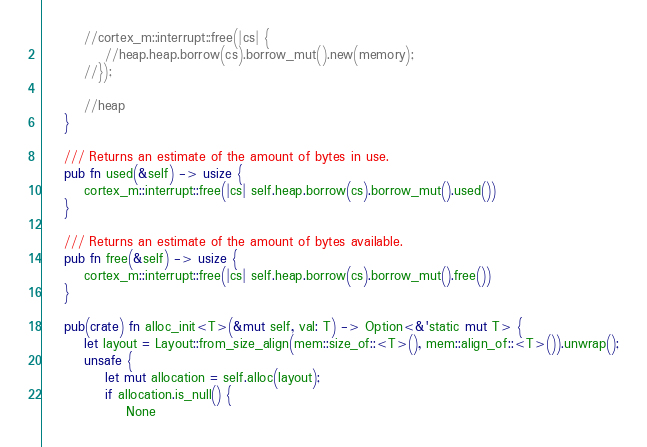<code> <loc_0><loc_0><loc_500><loc_500><_Rust_>
        //cortex_m::interrupt::free(|cs| {
            //heap.heap.borrow(cs).borrow_mut().new(memory);
        //});

        //heap
    }

    /// Returns an estimate of the amount of bytes in use.
    pub fn used(&self) -> usize {
        cortex_m::interrupt::free(|cs| self.heap.borrow(cs).borrow_mut().used())
    }

    /// Returns an estimate of the amount of bytes available.
    pub fn free(&self) -> usize {
        cortex_m::interrupt::free(|cs| self.heap.borrow(cs).borrow_mut().free())
    }

    pub(crate) fn alloc_init<T>(&mut self, val: T) -> Option<&'static mut T> {
        let layout = Layout::from_size_align(mem::size_of::<T>(), mem::align_of::<T>()).unwrap();
        unsafe {
            let mut allocation = self.alloc(layout);
            if allocation.is_null() {
                None</code> 